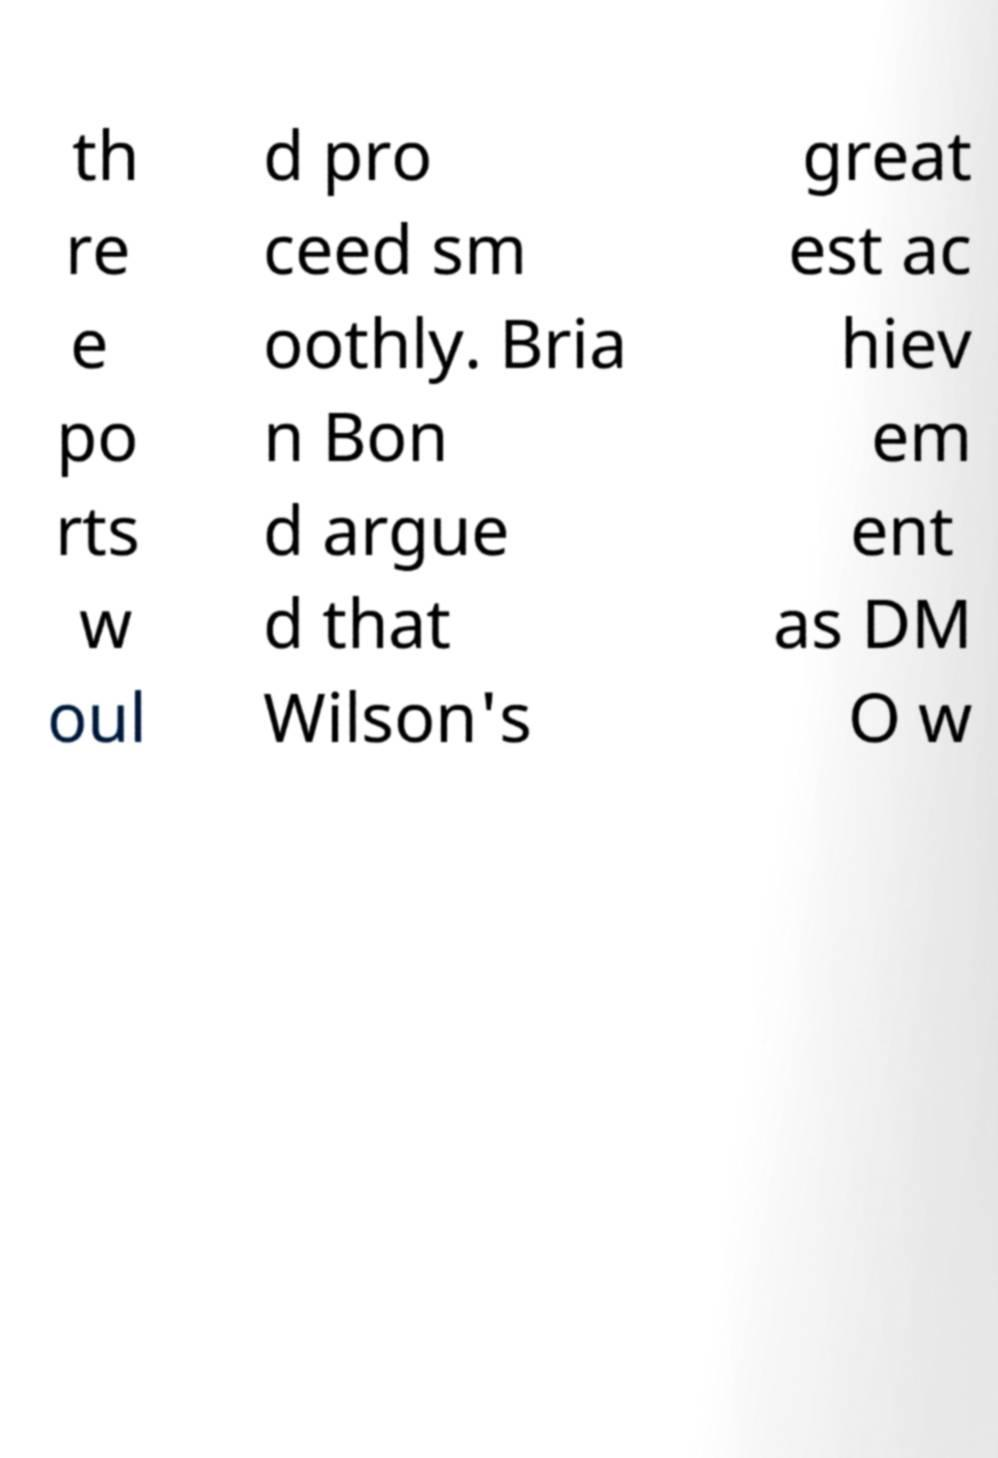I need the written content from this picture converted into text. Can you do that? th re e po rts w oul d pro ceed sm oothly. Bria n Bon d argue d that Wilson's great est ac hiev em ent as DM O w 